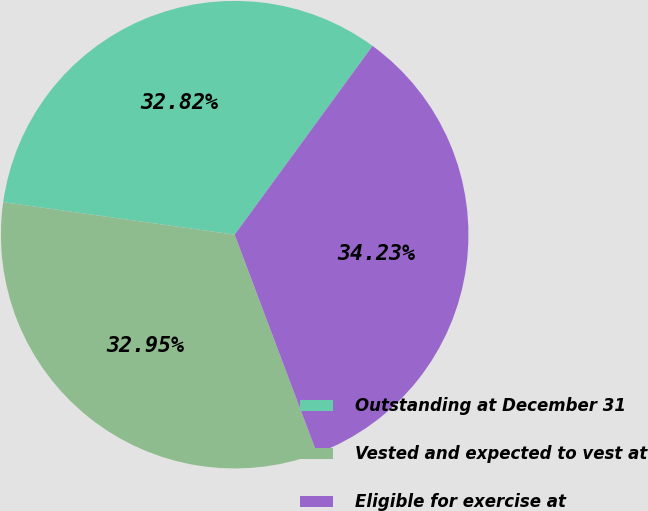<chart> <loc_0><loc_0><loc_500><loc_500><pie_chart><fcel>Outstanding at December 31<fcel>Vested and expected to vest at<fcel>Eligible for exercise at<nl><fcel>32.82%<fcel>32.95%<fcel>34.23%<nl></chart> 